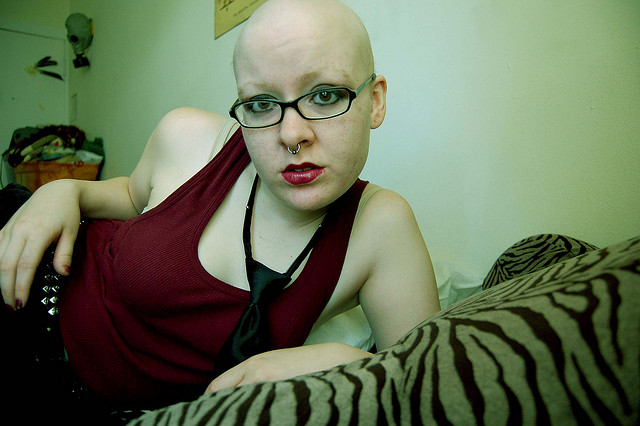<image>What color is the woman's hair? The woman may not have hair. So the color is undetermined. What figure is on the shirt? There is no figure on the shirt. What color is the woman's hair? I don't know the color of the woman's hair. It is not visible in the image. What figure is on the shirt? I am not sure what figure is on the shirt. It can be seen tie, woman, solid, or plain. 